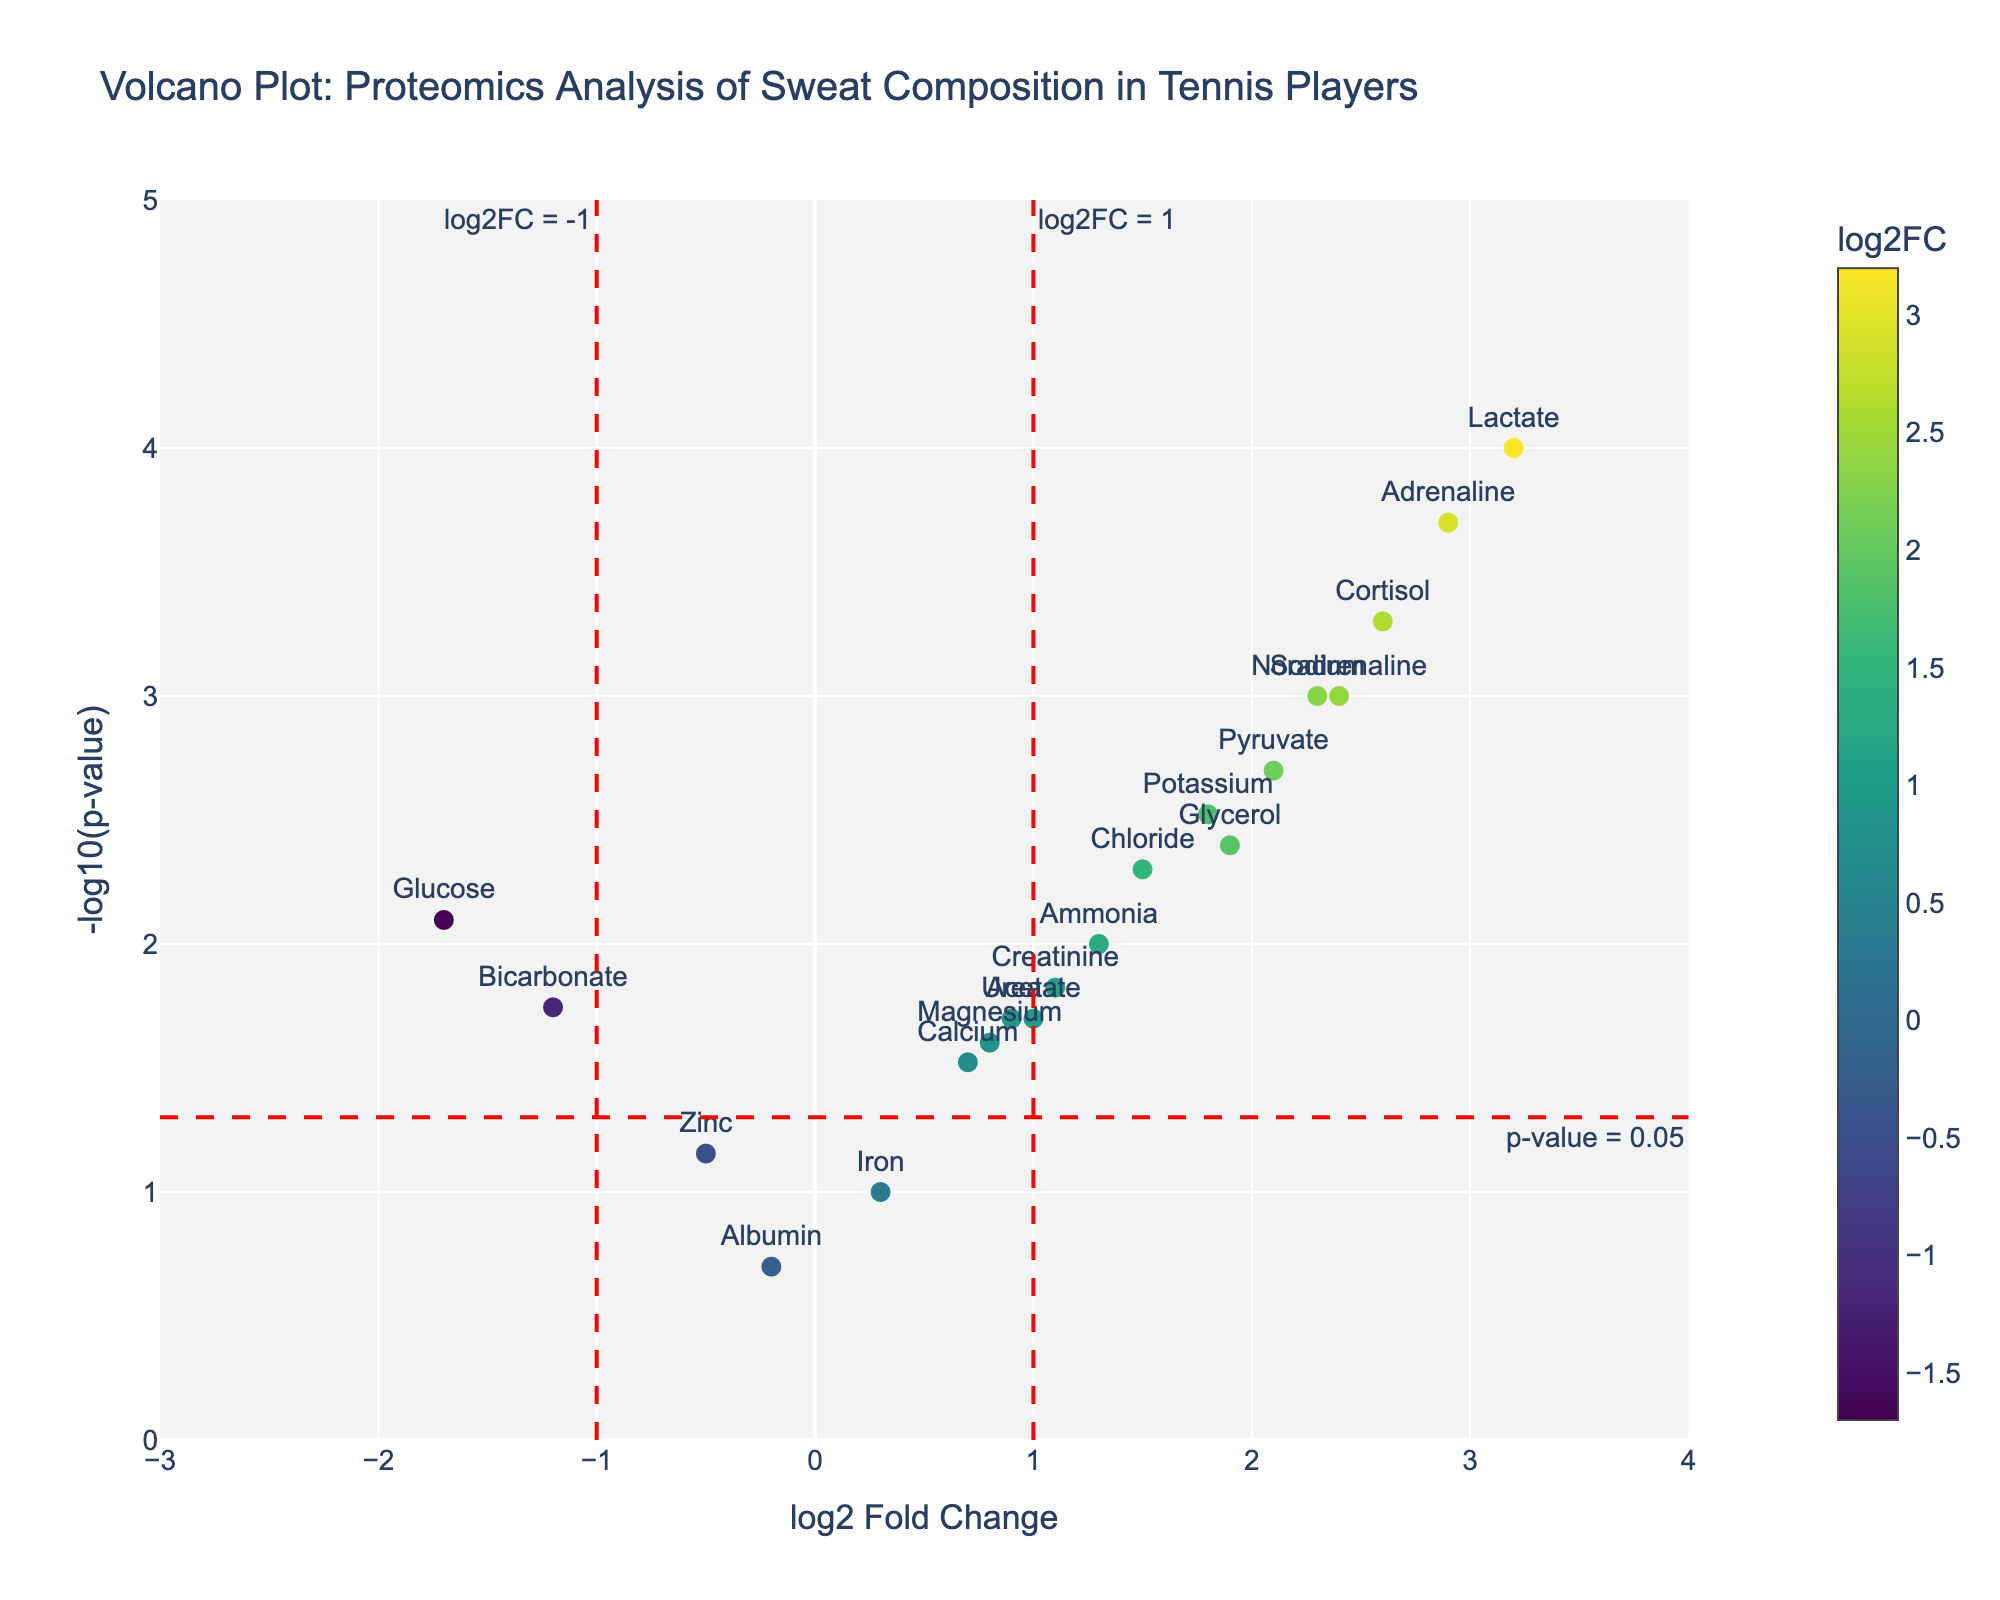Which protein has the highest log2 fold change? Look for the protein with the highest value on the x-axis. The protein with the highest log2 fold change is Lactate, at 3.2.
Answer: Lactate How many proteins have a p-value less than 0.01? Identify all data points above the horizontal red line at y = -log10(0.01). Count those proteins, including Sodium, Potassium, Chloride, Lactate, Cortisol, Adrenaline, and Noradrenaline.
Answer: 7 Which protein has a significant decrease in concentration after the match? Look for data points with negative log2 fold changes that are also above the horizontal red line. Glucose and Bicarbonate have significant decreases.
Answer: Glucose and Bicarbonate What is the log2 fold change and p-value for Adrenaline? Hover over the data point for Adrenaline, which shows its log2 fold change and p-value. Adrenaline has a log2 fold change of 2.9 and a p-value of 0.0002.
Answer: log2FC: 2.9, p-value: 0.0002 Which proteins show a log2 fold change greater than 1 and a p-value less than 0.05? Identify proteins that fall in the upper right quadrant, above both the horizontal red line and the right vertical red line. These include Sodium, Potassium, Chloride, Lactate, Cortisol, Adrenaline, Noradrenaline, Glycerol, and Pyruvate.
Answer: 9 proteins (Sodium, Potassium, Chloride, Lactate, Cortisol, Adrenaline, Noradrenaline, Glycerol, Pyruvate) Are there any proteins that are not significantly changed after the match? Look for data points lying below the horizontal red line (y = -log10(0.05)). Zinc, Iron, and Albumin lie below this threshold, indicating they are not significantly changed.
Answer: Zinc, Iron, Albumin Which proteins show a log2 fold change less than -1 and a p-value less than 0.05? Identify proteins that fall in the upper left quadrant, above the horizontal red line with negative log2 fold changes. The proteins are Glucose and Bicarbonate.
Answer: Glucose and Bicarbonate What is the significance threshold for the p-value in this plot? The red horizontal line represents the significance threshold for the p-value, which is at -log10(0.05).
Answer: 0.05 What is the significance threshold for log2 fold change in this plot? The red vertical lines at x = -1 and x = 1 represent the significance thresholds for log2 fold change.
Answer: -1 and 1 What does a positive log2 fold change indicate in terms of protein concentration before and after the match? A positive log2 fold change indicates that the concentration of the protein increased after the match compared to before.
Answer: Increased concentration 